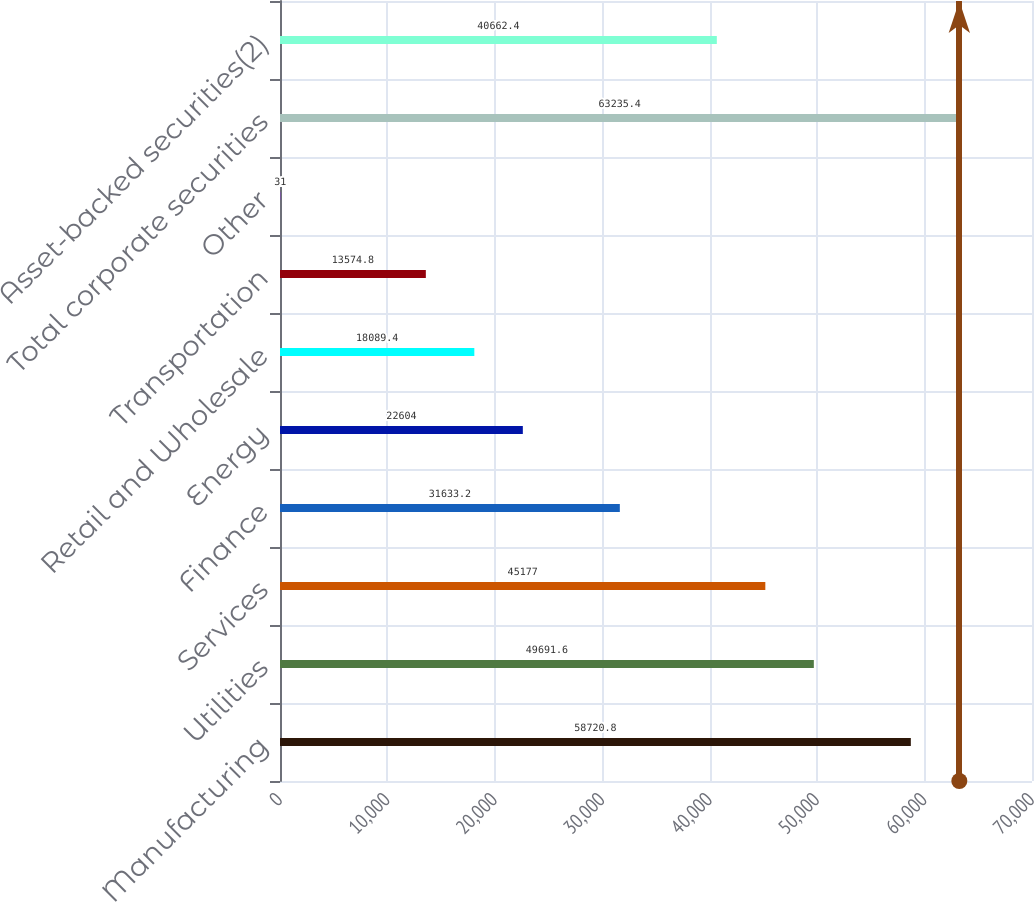<chart> <loc_0><loc_0><loc_500><loc_500><bar_chart><fcel>Manufacturing<fcel>Utilities<fcel>Services<fcel>Finance<fcel>Energy<fcel>Retail and Wholesale<fcel>Transportation<fcel>Other<fcel>Total corporate securities<fcel>Asset-backed securities(2)<nl><fcel>58720.8<fcel>49691.6<fcel>45177<fcel>31633.2<fcel>22604<fcel>18089.4<fcel>13574.8<fcel>31<fcel>63235.4<fcel>40662.4<nl></chart> 